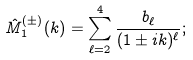Convert formula to latex. <formula><loc_0><loc_0><loc_500><loc_500>\hat { M } ^ { ( \pm ) } _ { 1 } ( k ) = \sum _ { \ell = 2 } ^ { 4 } \frac { b _ { \ell } } { ( 1 \pm i k ) ^ { \ell } } ;</formula> 